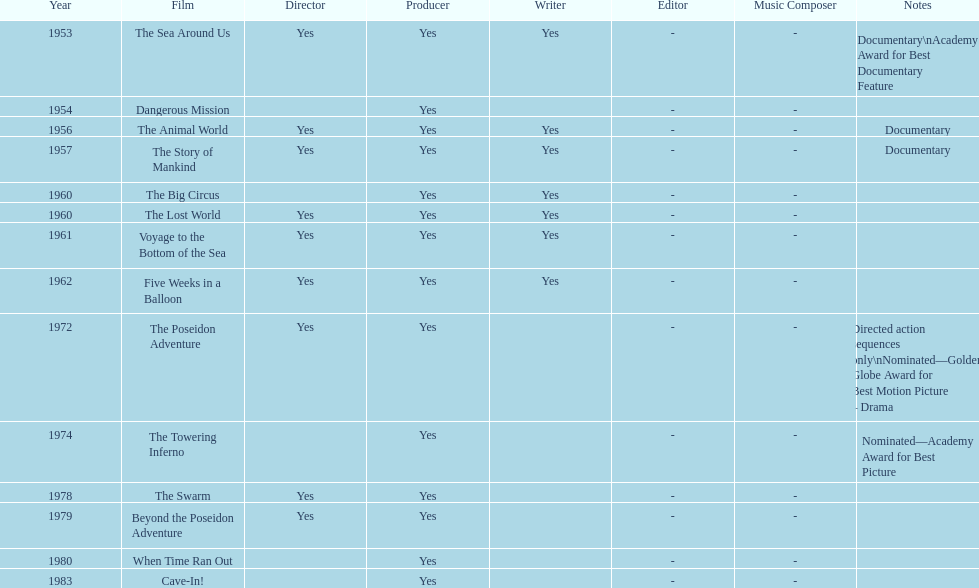How many films did irwin allen direct, produce and write? 6. 